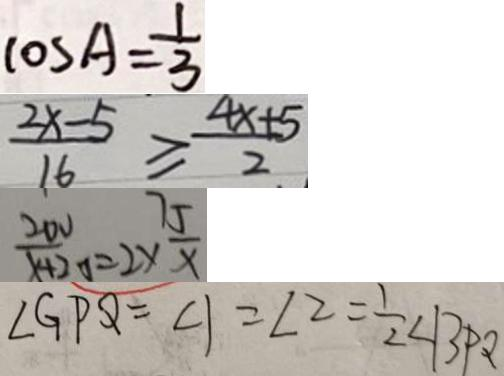Convert formula to latex. <formula><loc_0><loc_0><loc_500><loc_500>\cos A = \frac { 1 } { 3 } 
 \frac { 2 x - 5 } { 1 6 } \geq \frac { 4 x + 5 } { 2 } 
 \frac { 2 0 v } { x + 2 0 } = 2 \times \frac { 7 5 } { x } 
 \angle G P Q = \angle 1 = \angle 2 = \frac { 1 } { 2 } \angle B P Q</formula> 